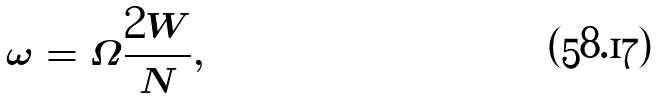<formula> <loc_0><loc_0><loc_500><loc_500>\omega = \Omega \frac { 2 W } { N } ,</formula> 